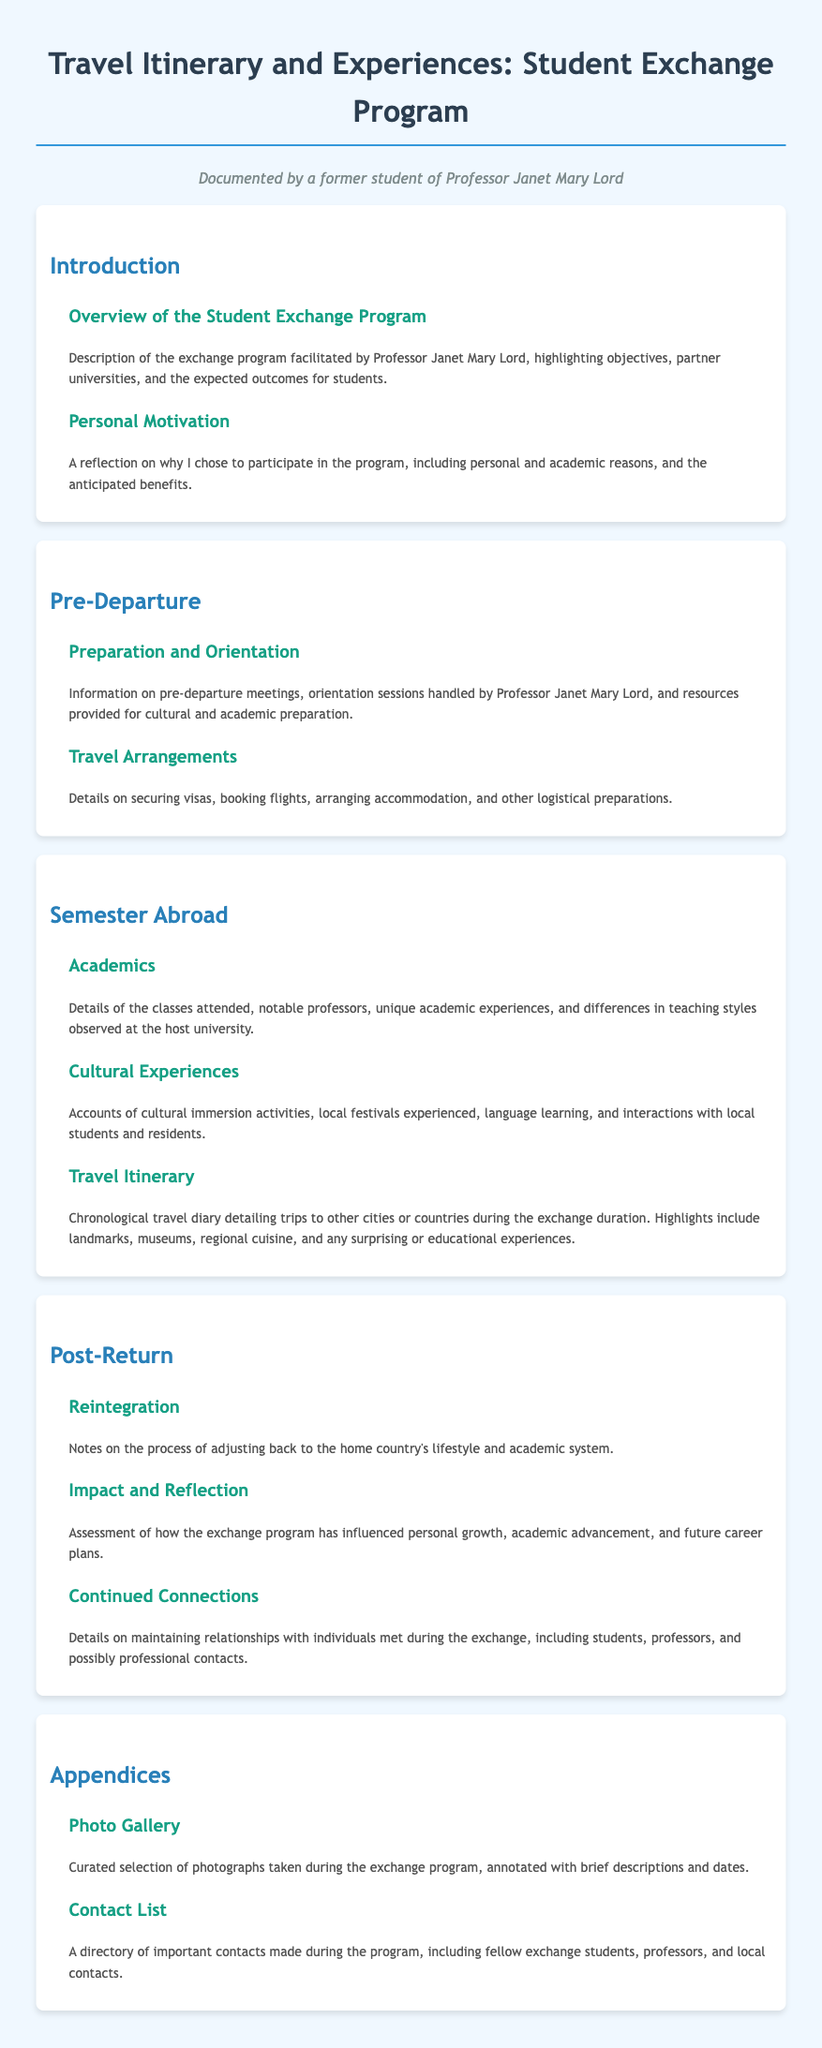what is the title of the document? The title of the document is stated in the header.
Answer: Travel Itinerary and Experiences: Student Exchange Program who facilitated the exchange program? The document mentions that Professor Janet Mary Lord facilitated the program.
Answer: Professor Janet Mary Lord what is covered in the preparation and orientation section? This section includes information on pre-departure meetings and resources for cultural and academic preparation.
Answer: Pre-departure meetings, orientation sessions, and resources how many subsections are in the Semester Abroad section? The document lists three subsections under the Semester Abroad section.
Answer: Three what kind of experiences does the Cultural Experiences subsection describe? It describes accounts of cultural immersion activities and interactions with local students and residents.
Answer: Cultural immersion activities and interactions what main topics are included in the Post-Return section? The section includes Reintegration, Impact and Reflection, and Continued Connections.
Answer: Reintegration, Impact and Reflection, Continued Connections what does the Photo Gallery appendix contain? The appendix includes a curated selection of photographs taken during the exchange program.
Answer: Curated selection of photographs who are the important contacts mentioned in the Contact List? The Contact List features fellow exchange students, professors, and local contacts.
Answer: Fellow exchange students, professors, and local contacts 